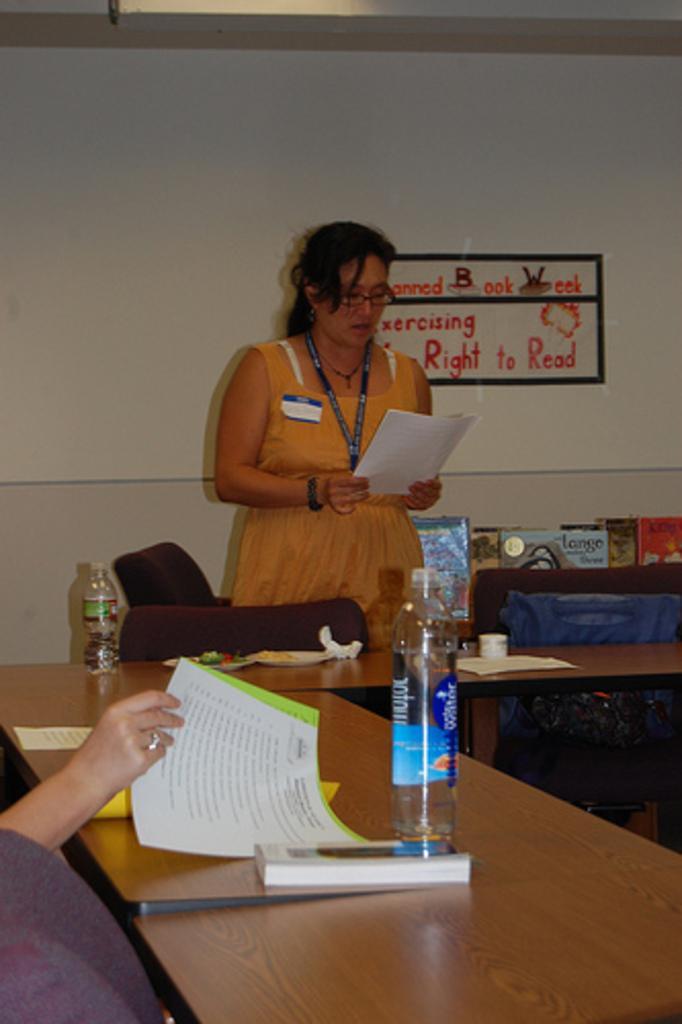Describe this image in one or two sentences. Here we can see a woman standing, and holding a papers in her hand, and in front here is the table and bottle and papers and some objects on it, and at back here is the wall. 